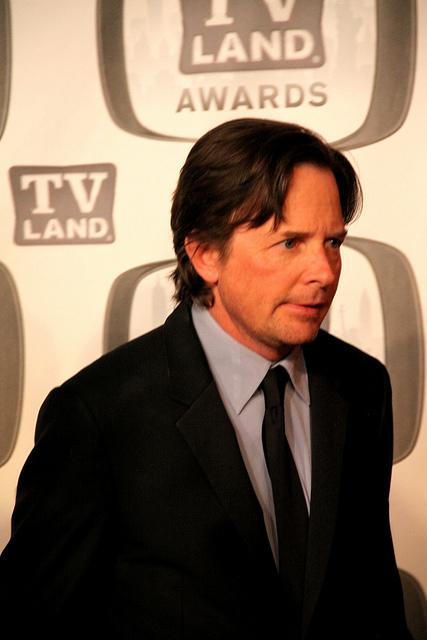Does he look mad?
Give a very brief answer. No. Is this an award show?
Answer briefly. Yes. Who is this?
Quick response, please. Michael j fox. 